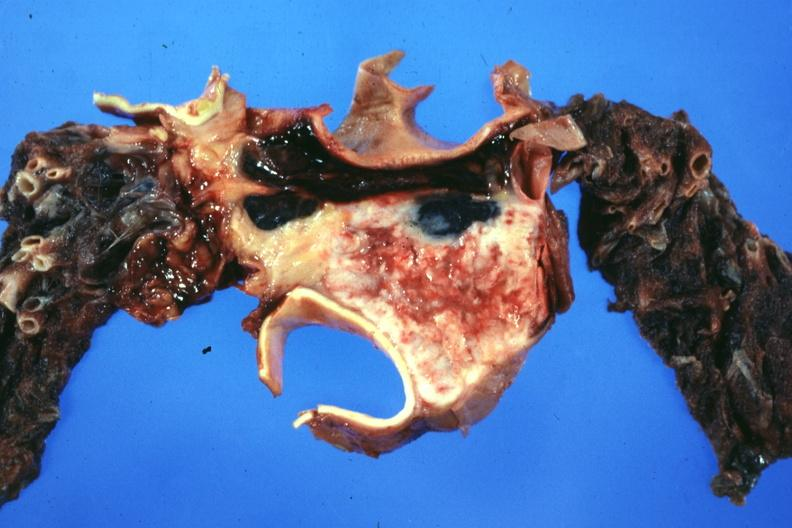s cm present?
Answer the question using a single word or phrase. No 